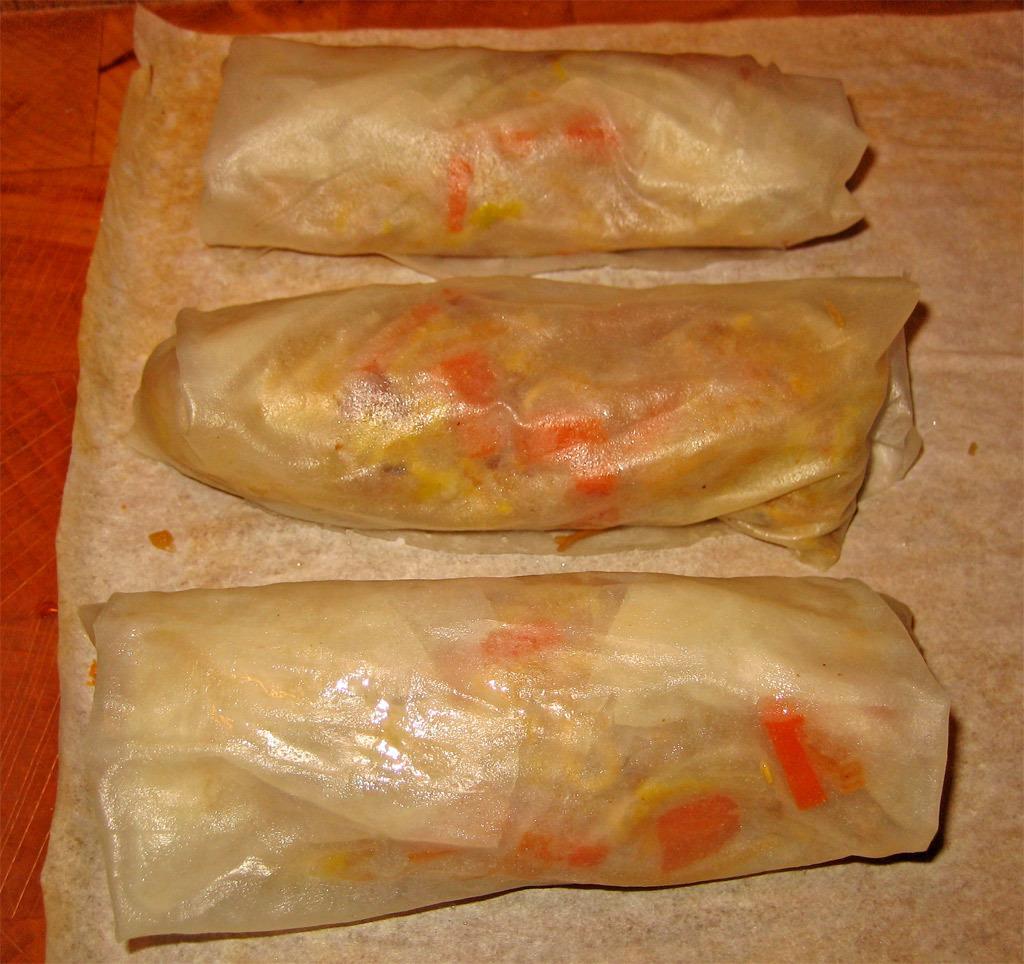Could you give a brief overview of what you see in this image? In this image we can see some food items are placed here. 